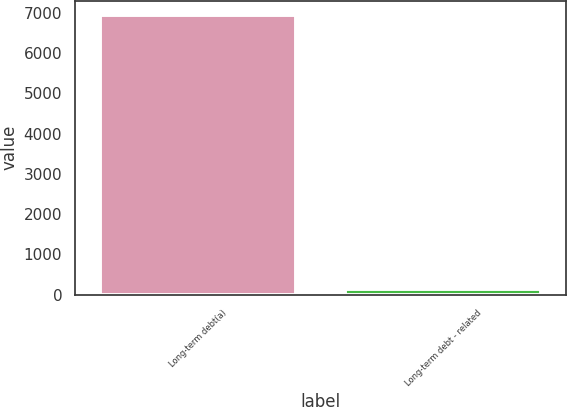Convert chart to OTSL. <chart><loc_0><loc_0><loc_500><loc_500><bar_chart><fcel>Long-term debt(a)<fcel>Long-term debt - related<nl><fcel>6946<fcel>155<nl></chart> 